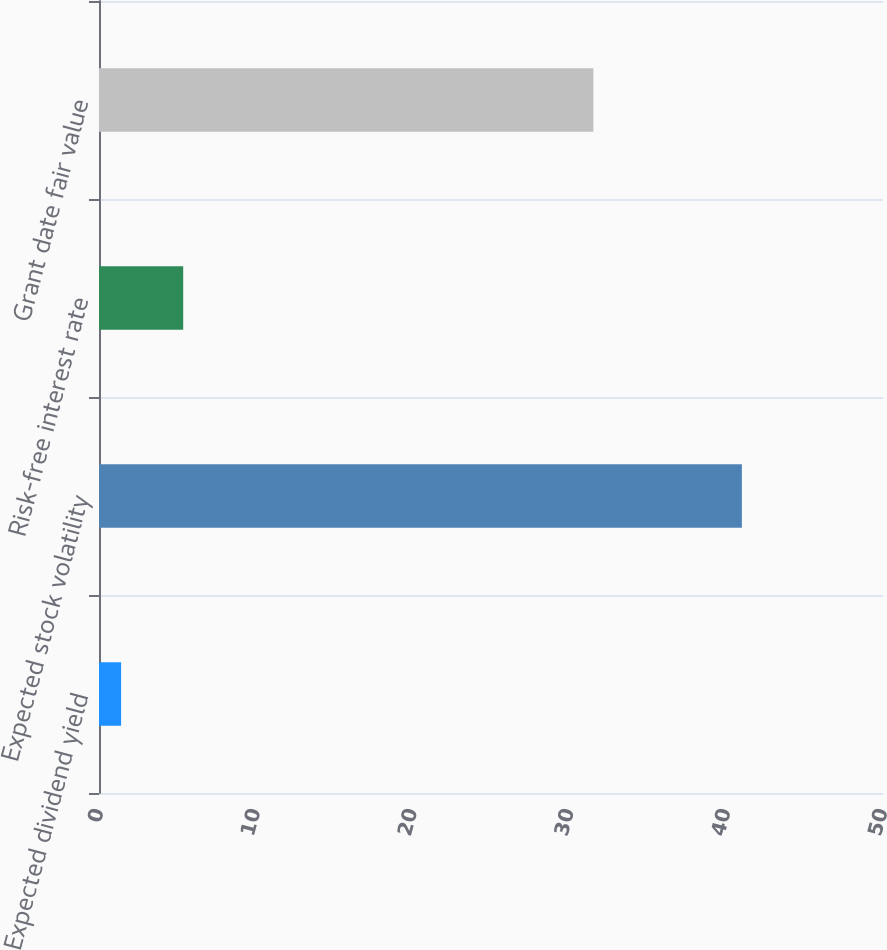Convert chart. <chart><loc_0><loc_0><loc_500><loc_500><bar_chart><fcel>Expected dividend yield<fcel>Expected stock volatility<fcel>Risk-free interest rate<fcel>Grant date fair value<nl><fcel>1.41<fcel>41<fcel>5.37<fcel>31.53<nl></chart> 